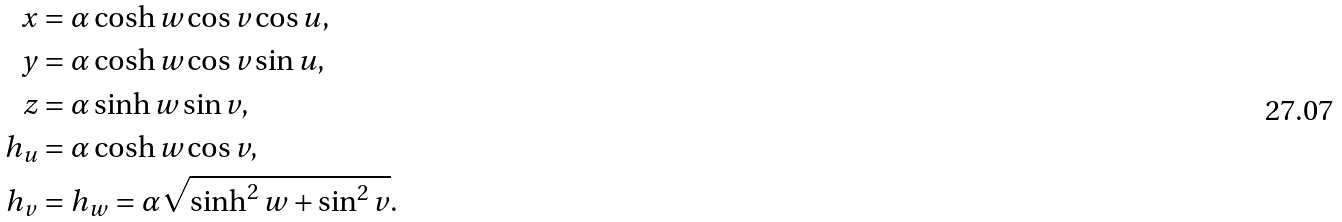<formula> <loc_0><loc_0><loc_500><loc_500>x & = \alpha \cosh w \cos v \cos u , \\ y & = \alpha \cosh w \cos v \sin u , \\ z & = \alpha \sinh w \sin v , \\ h _ { u } & = \alpha \cosh w \cos v , \\ h _ { v } & = h _ { w } = \alpha \sqrt { \sinh ^ { 2 } w + \sin ^ { 2 } v } .</formula> 